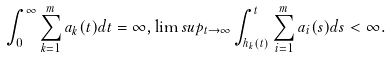<formula> <loc_0><loc_0><loc_500><loc_500>\int _ { 0 } ^ { \infty } \sum _ { k = 1 } ^ { m } a _ { k } ( t ) d t = \infty , \lim s u p _ { t \rightarrow \infty } \int _ { h _ { k } ( t ) } ^ { t } \sum _ { i = 1 } ^ { m } a _ { i } ( s ) d s < \infty .</formula> 